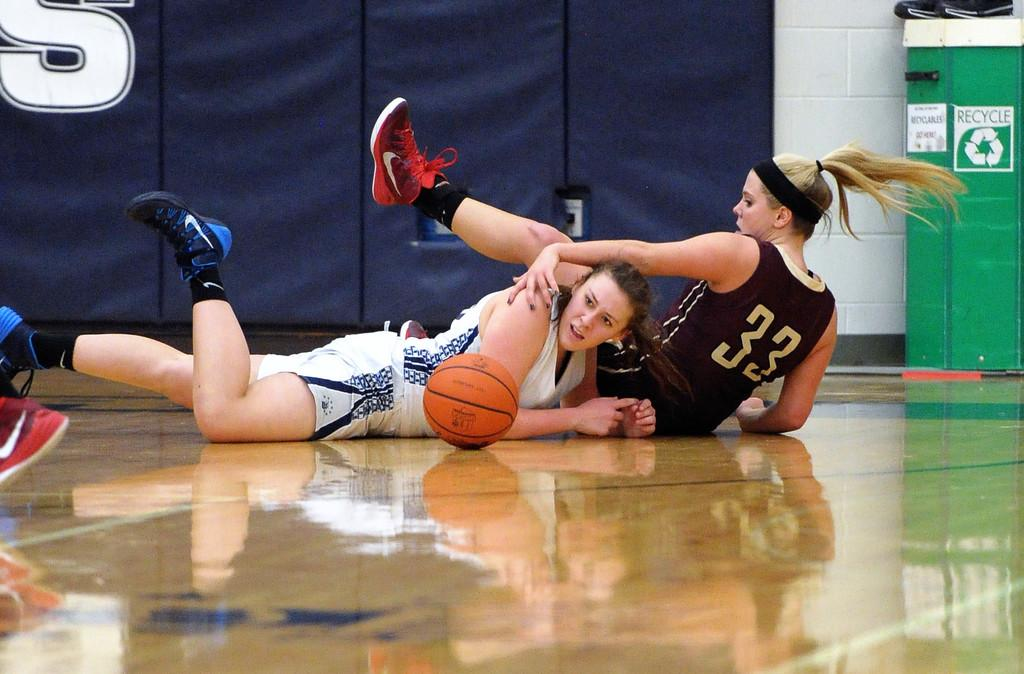Provide a one-sentence caption for the provided image. Two basketball players on the ground with a Recycle bin in the background. 